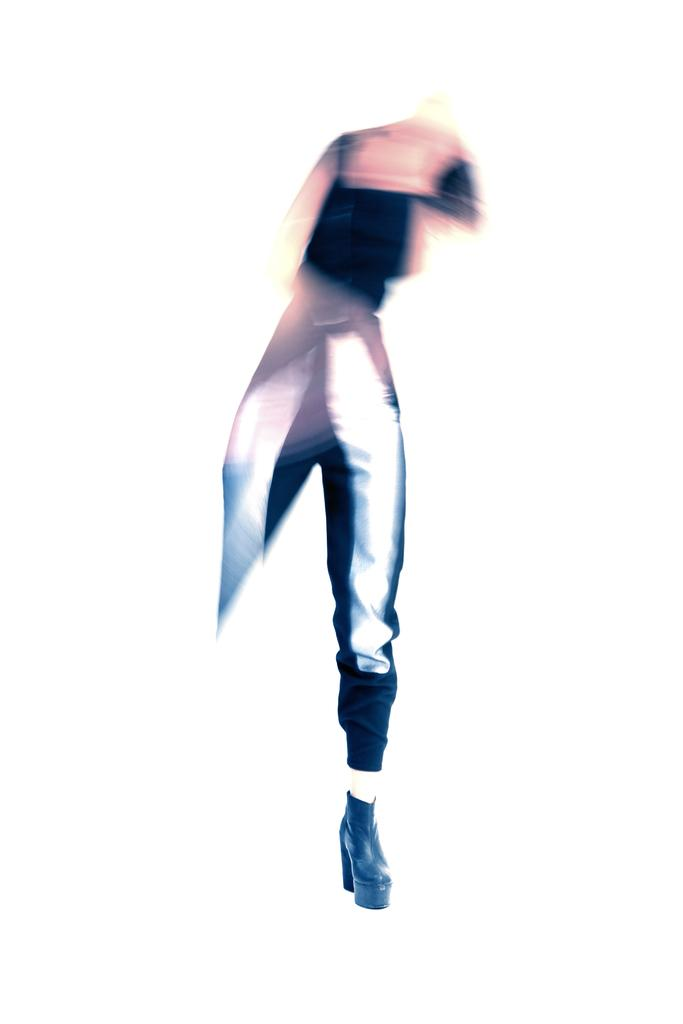What part of a person's body is visible in the image? There is a person's leg in the image. What color are the pants worn by the person in the image? The person's leg is wearing black-colored pants. What is the color of the background in the image? The background of the image is white. What type of pail is being used for the discussion in the image? There is no pail or discussion present in the image; it only features a person's leg wearing black-colored pants against a white background. 